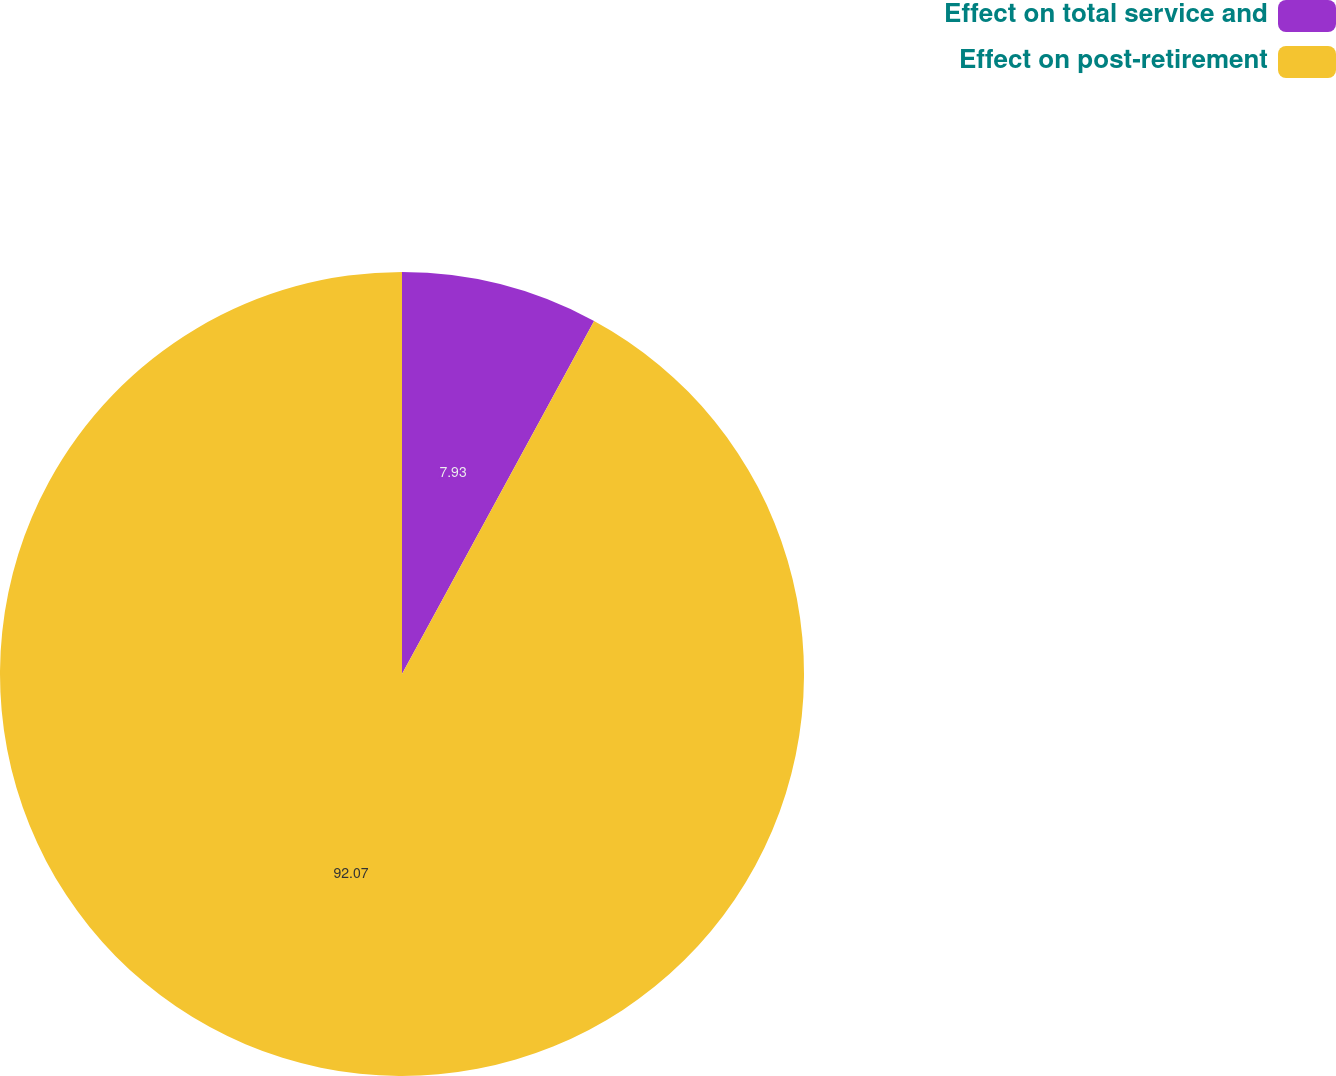Convert chart. <chart><loc_0><loc_0><loc_500><loc_500><pie_chart><fcel>Effect on total service and<fcel>Effect on post-retirement<nl><fcel>7.93%<fcel>92.07%<nl></chart> 